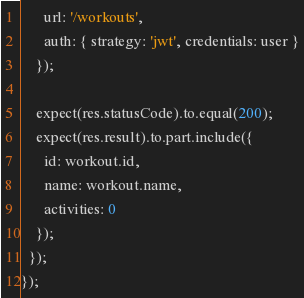<code> <loc_0><loc_0><loc_500><loc_500><_JavaScript_>      url: '/workouts',
      auth: { strategy: 'jwt', credentials: user }
    });

    expect(res.statusCode).to.equal(200);
    expect(res.result).to.part.include({
      id: workout.id,
      name: workout.name,
      activities: 0
    });
  });
});
</code> 